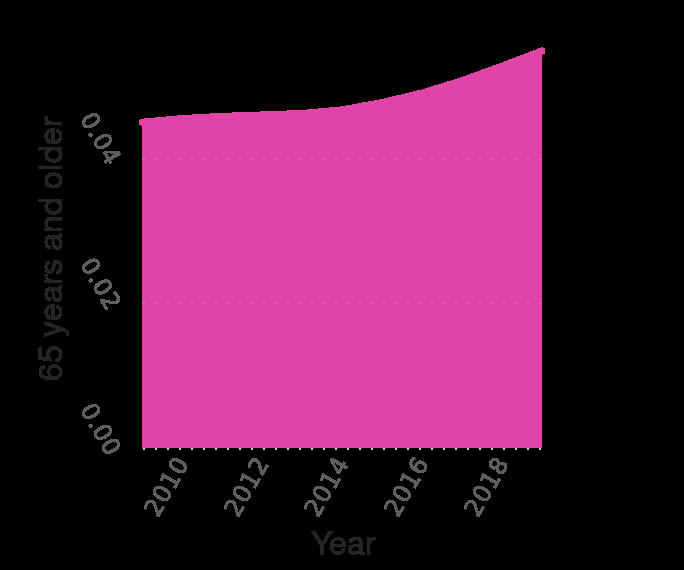<image>
please describe the details of the chart Here a area chart is labeled Nicaragua : Age structure from 2009 to 2019. There is a linear scale of range 2010 to 2018 along the x-axis, labeled Year. A linear scale of range 0.00 to 0.04 can be found along the y-axis, marked 65 years and older. What is the title of the chart?  The title of the chart is "Nicaragua: Age structure from 2009 to 2019." What is the highest value mentioned in the figure?  The highest value mentioned in the figure is for the age group 65 and over. 